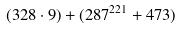Convert formula to latex. <formula><loc_0><loc_0><loc_500><loc_500>( 3 2 8 \cdot 9 ) + ( 2 8 7 ^ { 2 2 1 } + 4 7 3 )</formula> 